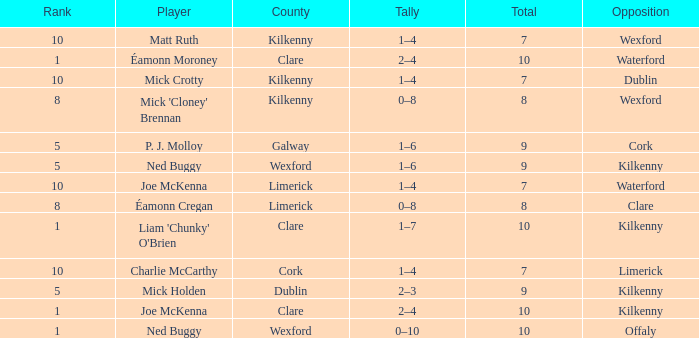Which Total has a County of kilkenny, and a Tally of 1–4, and a Rank larger than 10? None. 